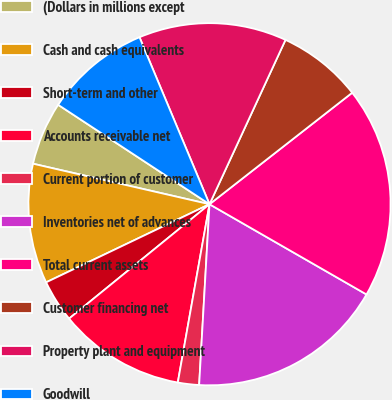Convert chart. <chart><loc_0><loc_0><loc_500><loc_500><pie_chart><fcel>(Dollars in millions except<fcel>Cash and cash equivalents<fcel>Short-term and other<fcel>Accounts receivable net<fcel>Current portion of customer<fcel>Inventories net of advances<fcel>Total current assets<fcel>Customer financing net<fcel>Property plant and equipment<fcel>Goodwill<nl><fcel>5.66%<fcel>10.69%<fcel>3.78%<fcel>11.32%<fcel>1.89%<fcel>17.61%<fcel>18.86%<fcel>7.55%<fcel>13.21%<fcel>9.43%<nl></chart> 